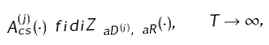<formula> <loc_0><loc_0><loc_500><loc_500>A _ { c s } ^ { ( j ) } ( \cdot ) \ f i d i Z _ { \ a D ^ { ( j ) } , \ a R } ( \cdot ) , \quad T \to \infty ,</formula> 